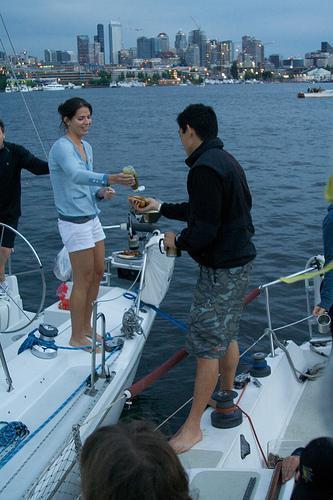How many people are in this picture?
Give a very brief answer. 5. How many boats can you see in the foreground?
Give a very brief answer. 2. 